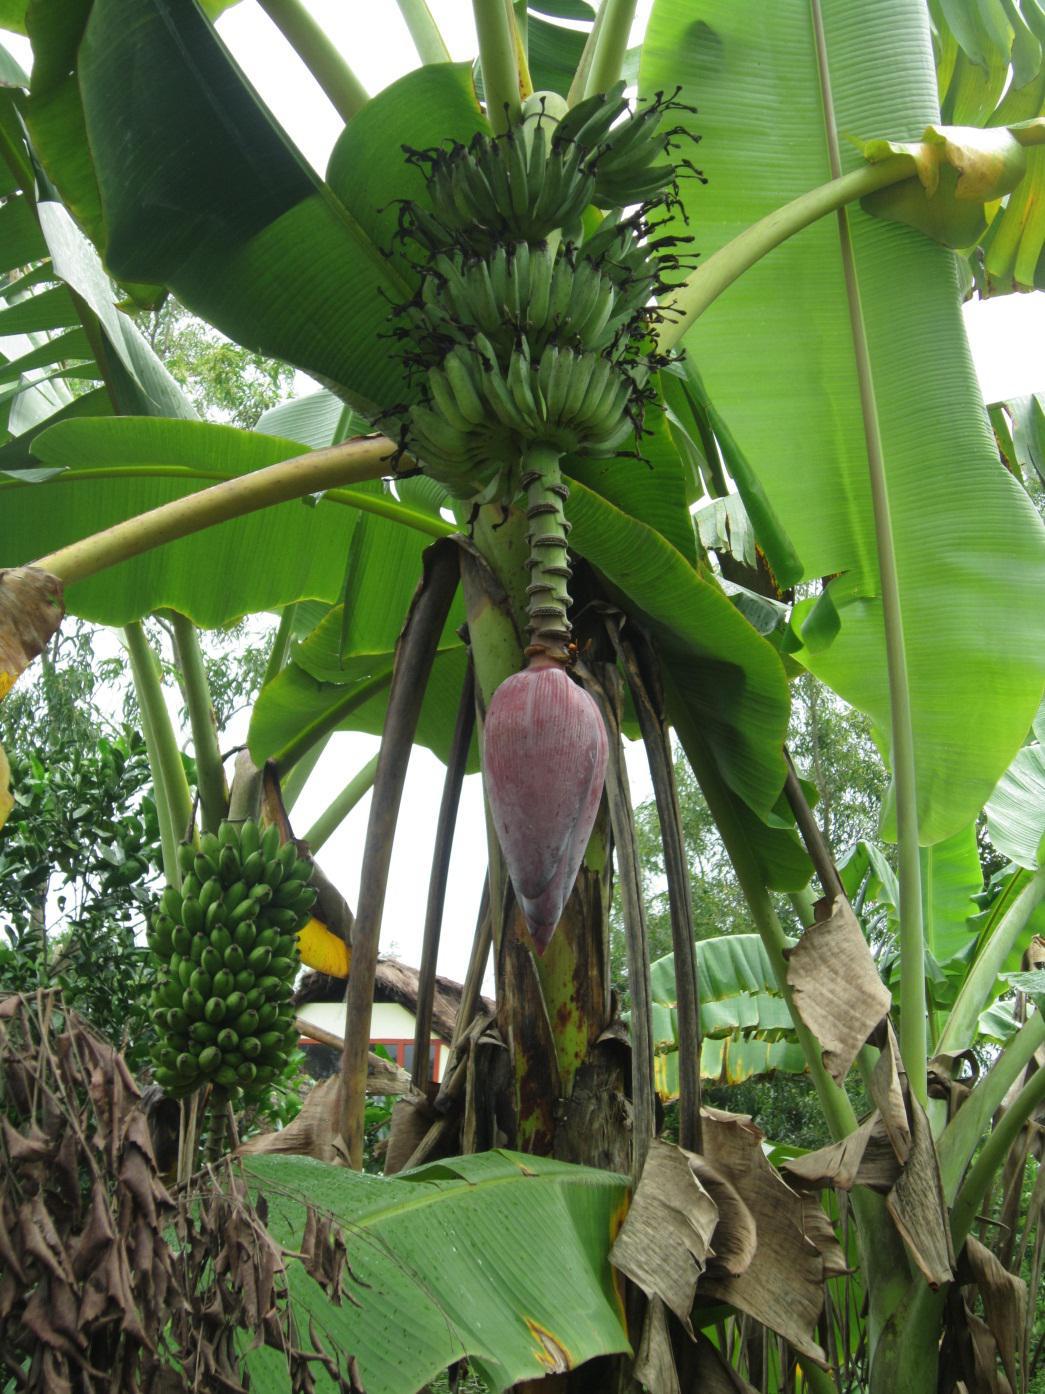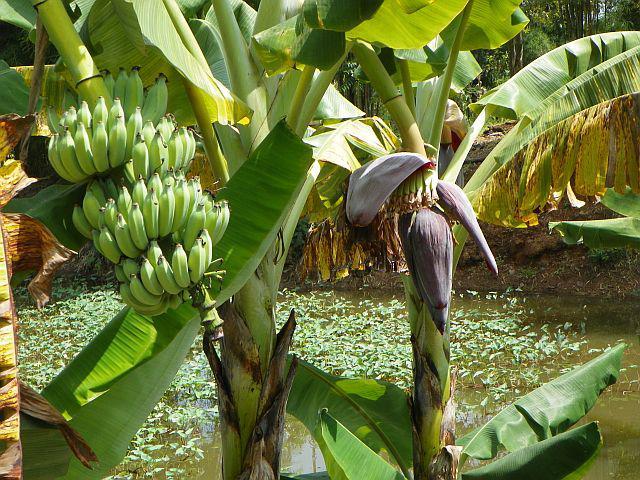The first image is the image on the left, the second image is the image on the right. Examine the images to the left and right. Is the description "One image shows a large purple bud with no open petals hanging under multiple tiers of green bananas." accurate? Answer yes or no. Yes. 